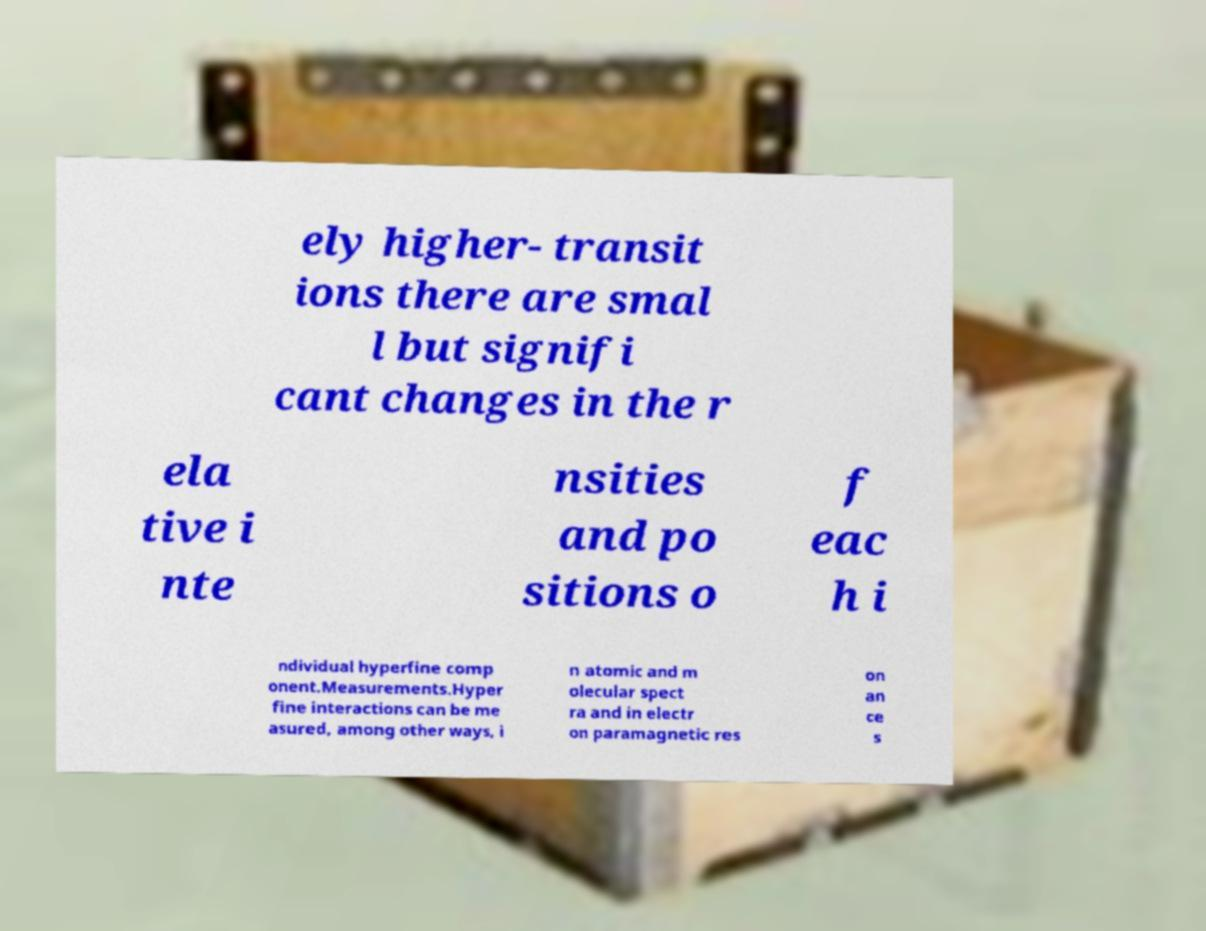For documentation purposes, I need the text within this image transcribed. Could you provide that? ely higher- transit ions there are smal l but signifi cant changes in the r ela tive i nte nsities and po sitions o f eac h i ndividual hyperfine comp onent.Measurements.Hyper fine interactions can be me asured, among other ways, i n atomic and m olecular spect ra and in electr on paramagnetic res on an ce s 